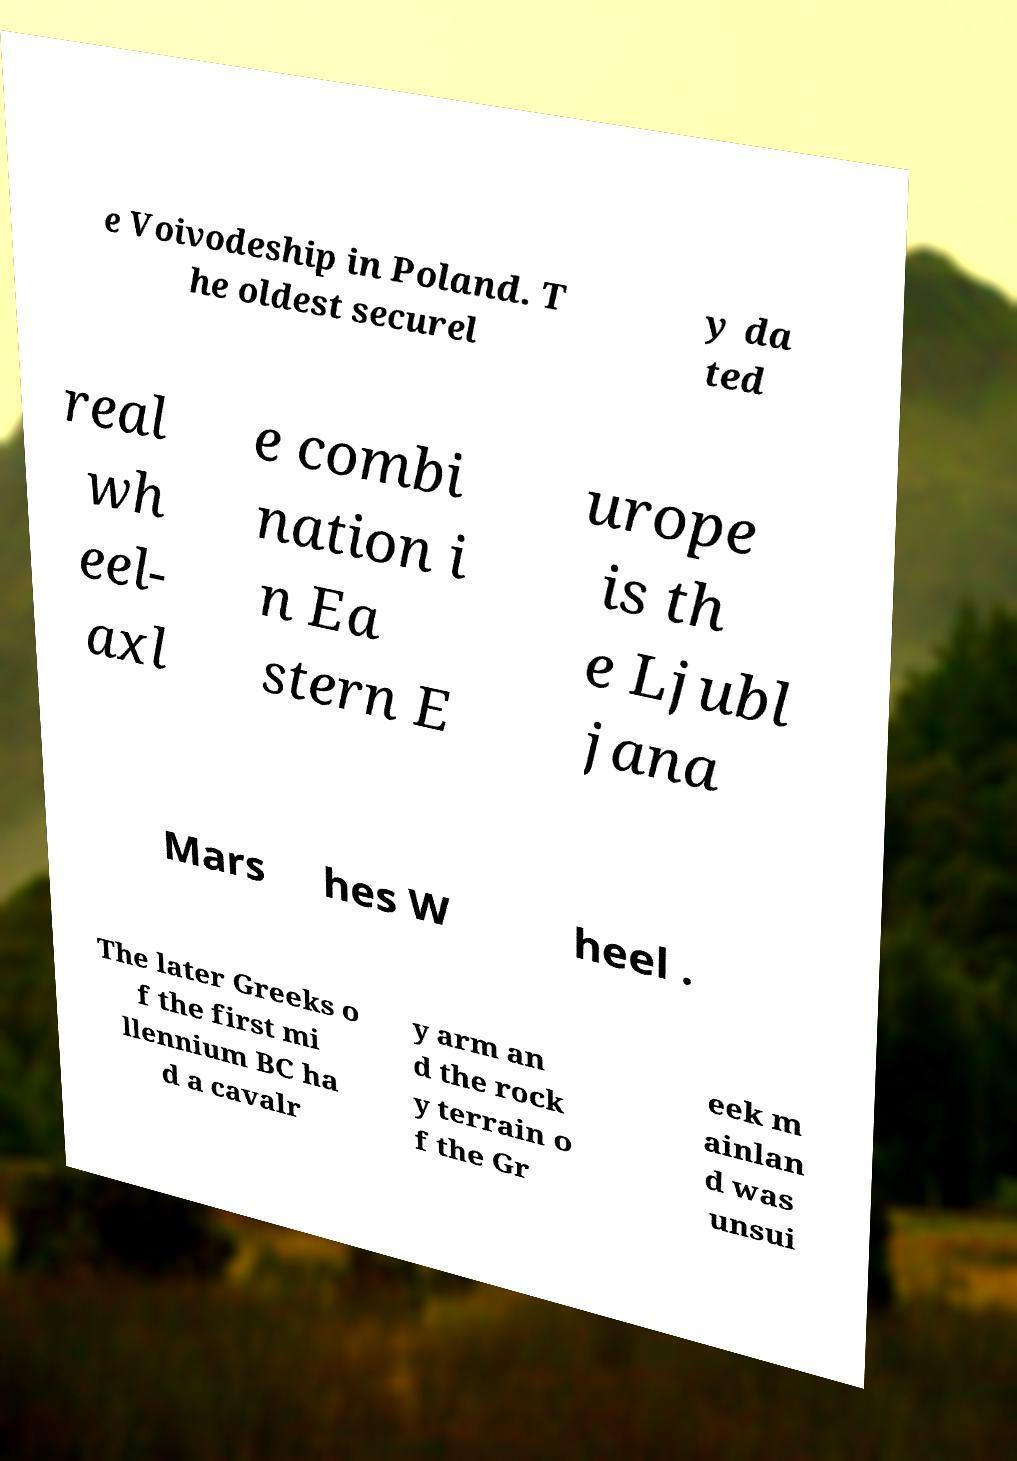There's text embedded in this image that I need extracted. Can you transcribe it verbatim? e Voivodeship in Poland. T he oldest securel y da ted real wh eel- axl e combi nation i n Ea stern E urope is th e Ljubl jana Mars hes W heel . The later Greeks o f the first mi llennium BC ha d a cavalr y arm an d the rock y terrain o f the Gr eek m ainlan d was unsui 